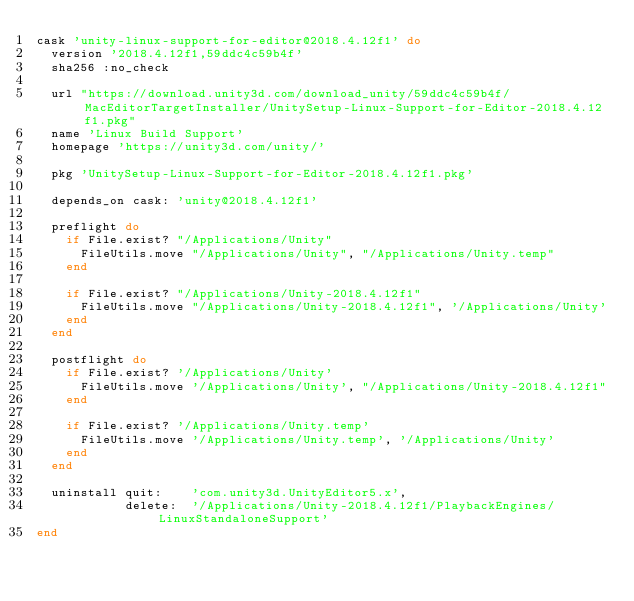Convert code to text. <code><loc_0><loc_0><loc_500><loc_500><_Ruby_>cask 'unity-linux-support-for-editor@2018.4.12f1' do
  version '2018.4.12f1,59ddc4c59b4f'
  sha256 :no_check

  url "https://download.unity3d.com/download_unity/59ddc4c59b4f/MacEditorTargetInstaller/UnitySetup-Linux-Support-for-Editor-2018.4.12f1.pkg"
  name 'Linux Build Support'
  homepage 'https://unity3d.com/unity/'

  pkg 'UnitySetup-Linux-Support-for-Editor-2018.4.12f1.pkg'

  depends_on cask: 'unity@2018.4.12f1'

  preflight do
    if File.exist? "/Applications/Unity"
      FileUtils.move "/Applications/Unity", "/Applications/Unity.temp"
    end

    if File.exist? "/Applications/Unity-2018.4.12f1"
      FileUtils.move "/Applications/Unity-2018.4.12f1", '/Applications/Unity'
    end
  end

  postflight do
    if File.exist? '/Applications/Unity'
      FileUtils.move '/Applications/Unity', "/Applications/Unity-2018.4.12f1"
    end

    if File.exist? '/Applications/Unity.temp'
      FileUtils.move '/Applications/Unity.temp', '/Applications/Unity'
    end
  end

  uninstall quit:    'com.unity3d.UnityEditor5.x',
            delete:  '/Applications/Unity-2018.4.12f1/PlaybackEngines/LinuxStandaloneSupport'
end
</code> 